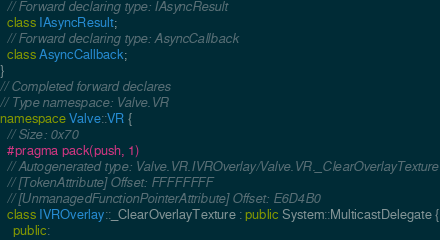<code> <loc_0><loc_0><loc_500><loc_500><_C++_>  // Forward declaring type: IAsyncResult
  class IAsyncResult;
  // Forward declaring type: AsyncCallback
  class AsyncCallback;
}
// Completed forward declares
// Type namespace: Valve.VR
namespace Valve::VR {
  // Size: 0x70
  #pragma pack(push, 1)
  // Autogenerated type: Valve.VR.IVROverlay/Valve.VR._ClearOverlayTexture
  // [TokenAttribute] Offset: FFFFFFFF
  // [UnmanagedFunctionPointerAttribute] Offset: E6D4B0
  class IVROverlay::_ClearOverlayTexture : public System::MulticastDelegate {
    public:</code> 